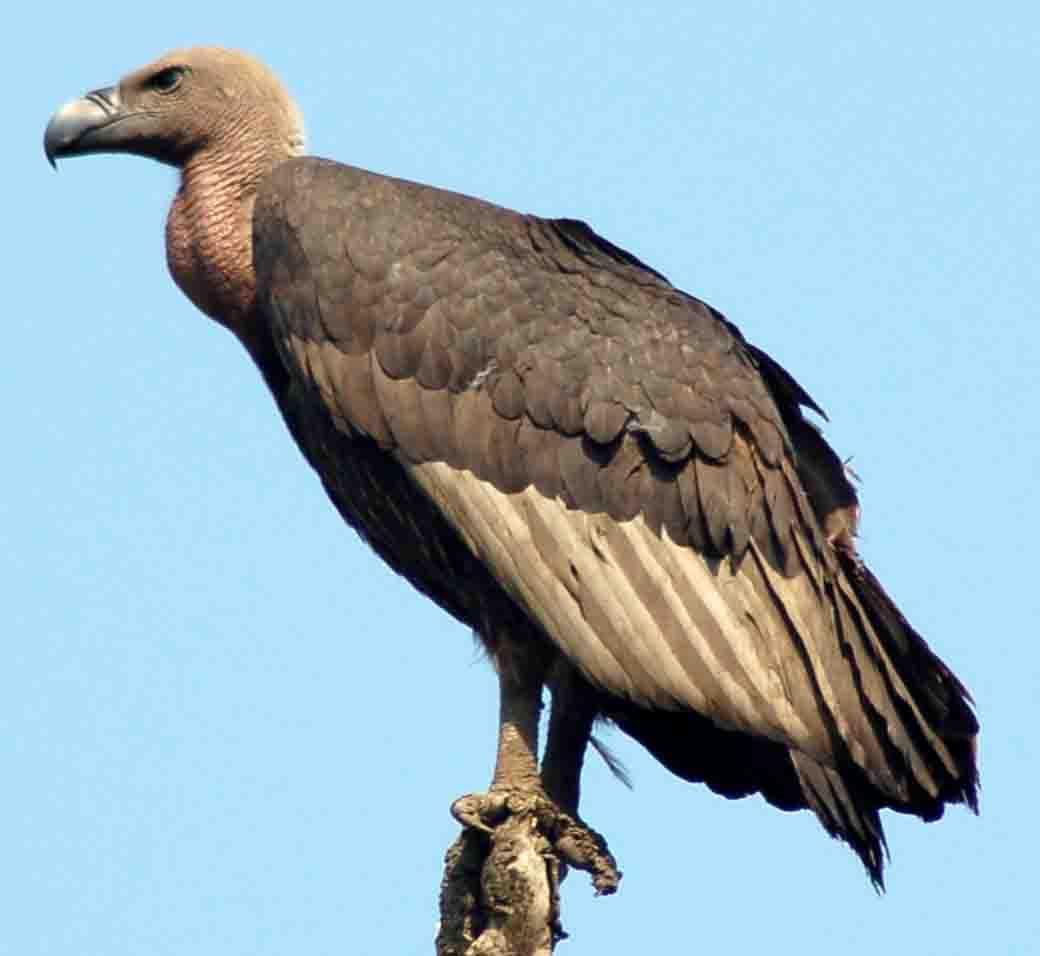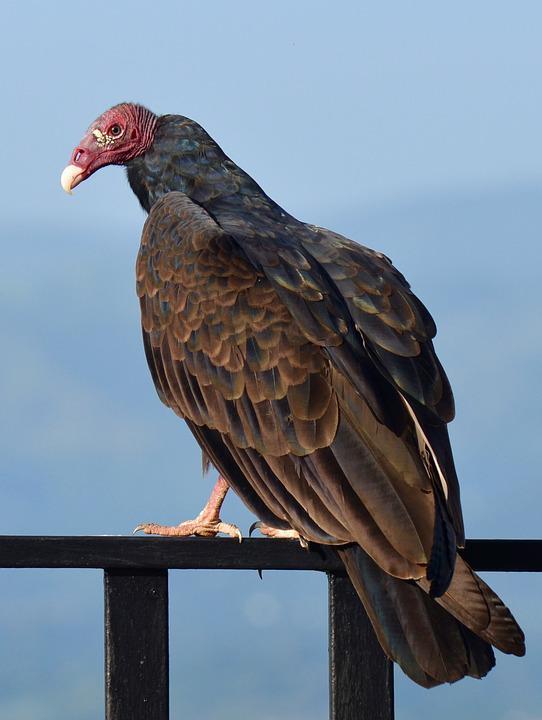The first image is the image on the left, the second image is the image on the right. Evaluate the accuracy of this statement regarding the images: "Both birds are facing the same direction.". Is it true? Answer yes or no. Yes. 